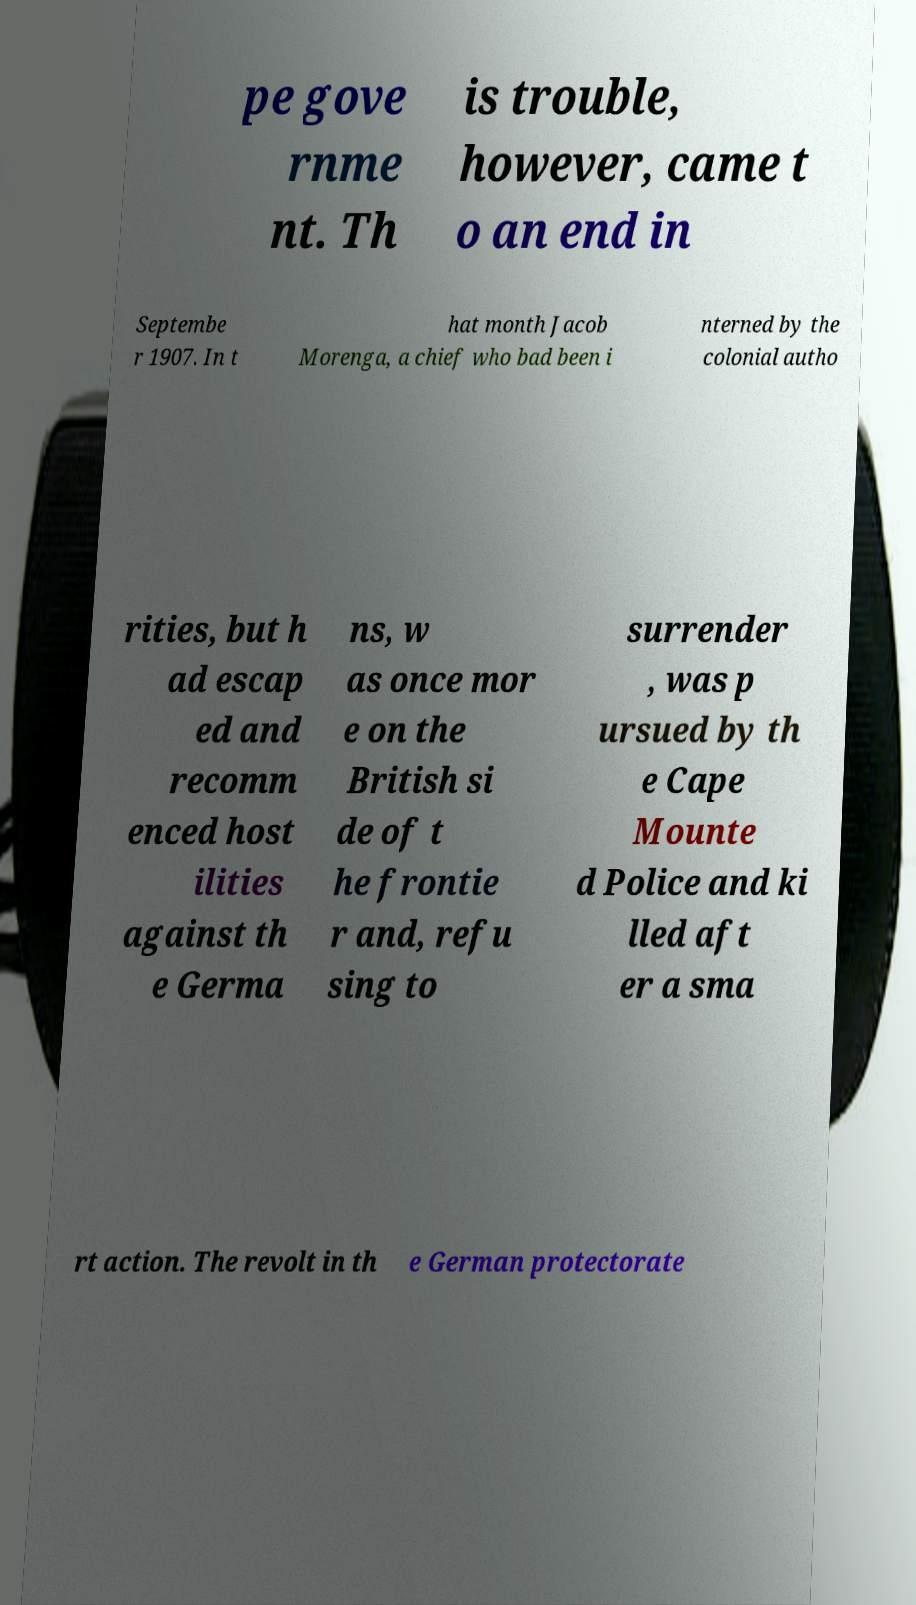Please read and relay the text visible in this image. What does it say? pe gove rnme nt. Th is trouble, however, came t o an end in Septembe r 1907. In t hat month Jacob Morenga, a chief who bad been i nterned by the colonial autho rities, but h ad escap ed and recomm enced host ilities against th e Germa ns, w as once mor e on the British si de of t he frontie r and, refu sing to surrender , was p ursued by th e Cape Mounte d Police and ki lled aft er a sma rt action. The revolt in th e German protectorate 